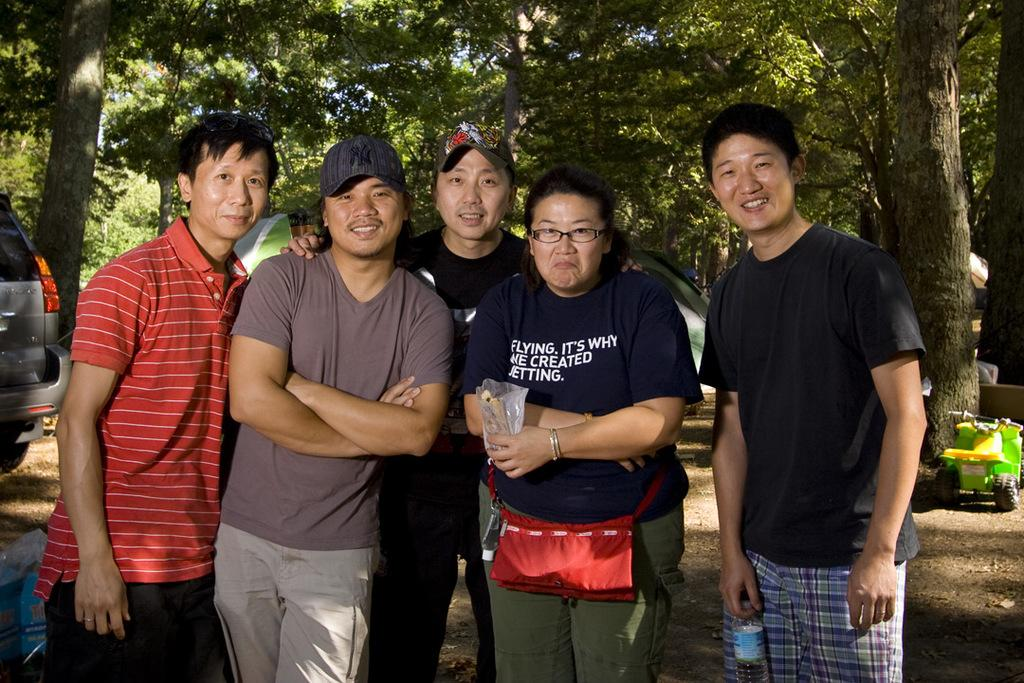What are the people in the image doing? The people in the image are standing. What is the man holding in his hand? The man is holding a water bottle in his hand. What can be seen in the background of the image? There are trees visible in the background of the image. What is parked on the road in the image? There is a vehicle parked on the road in the image. What type of stew is being served to the pets in the image? There are no pets or stew present in the image. What do the people in the image believe about the vehicle parked on the road? The image does not provide any information about the beliefs of the people in the image. 